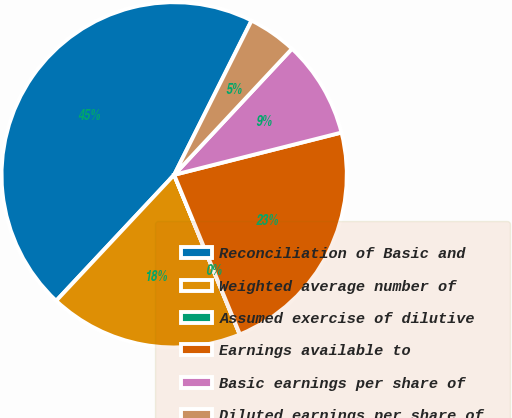<chart> <loc_0><loc_0><loc_500><loc_500><pie_chart><fcel>Reconciliation of Basic and<fcel>Weighted average number of<fcel>Assumed exercise of dilutive<fcel>Earnings available to<fcel>Basic earnings per share of<fcel>Diluted earnings per share of<nl><fcel>45.42%<fcel>18.18%<fcel>0.02%<fcel>22.72%<fcel>9.1%<fcel>4.56%<nl></chart> 